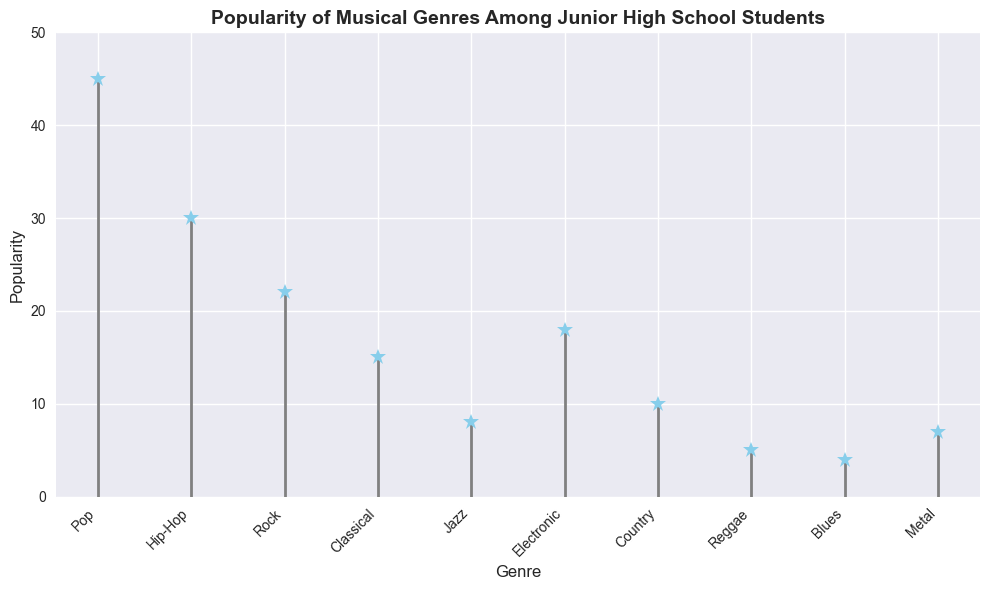Which genre has the highest popularity among junior high school students? The stem plot shows the popularity values for all the genres, where Pop has the highest marker at 45.
Answer: Pop Which genres have less than 10 popularity? From the stem plot, we can identify the genres with popularity values below 10: Jazz (8), Reggae (5), Blues (4), and Metal (7).
Answer: Jazz, Reggae, Blues, Metal How does the popularity of Hip-Hop compare to Rock? By observing the markers, Hip-Hop has a higher value (30) than Rock (22).
Answer: Hip-Hop is more popular than Rock What is the total popularity of Classical, Jazz, and Country genres? Summing the popularity values for Classical (15), Jazz (8), and Country (10) gives 15 + 8 + 10 = 33.
Answer: 33 Which genre has a popularity closest to the average popularity of all genres? Calculating the total popularity for all genres and dividing by the number of genres: (45 + 30 + 22 + 15 + 8 + 18 + 10 + 5 + 4 + 7) / 10 = 16.4. The closest genre to 16.4 is Electronic with a popularity of 18.
Answer: Electronic What is the popularity range of the genres presented? The range is given by the difference between the highest and the lowest popularity values. The highest popularity is 45 (Pop) and the lowest is 4 (Blues). So, 45 - 4 = 41.
Answer: 41 Which genre appears right next to Country in terms of popularity ranking? Country has a popularity of 10. The closest values are Jazz (8, less) and Metal (7, less), and Electronic (18, more) which ranks next higher in popularity.
Answer: Electronic and Jazz Compare the combined popularity of Reggae, Blues, and Metal with Electronic. Which has more? Summing popularity for Reggae (5), Blues (4), and Metal (7) gives 5 + 4 + 7 = 16. Electronic alone has 18.
Answer: Electronic has more How many genres have a popularity above 20? The plot shows that Pop (45), Hip-Hop (30), and Rock (22) have popularity above 20.
Answer: 3 genres 